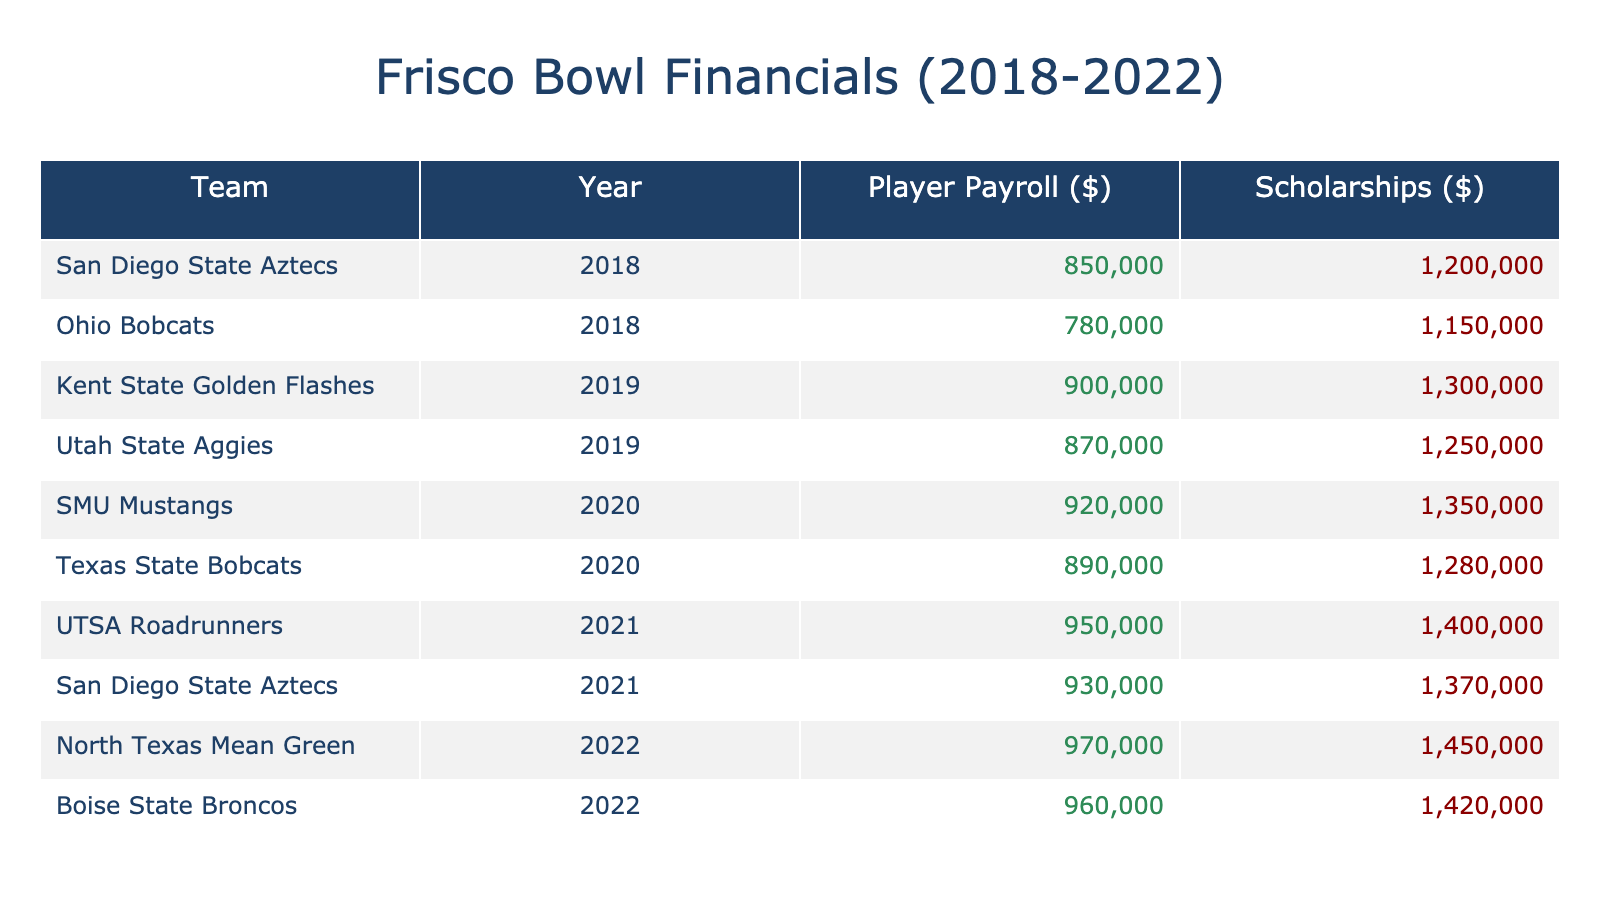What was the player payroll for the Ohio Bobcats in 2018? The table shows that the player payroll for the Ohio Bobcats in 2018 is $780,000.
Answer: $780,000 Which team had the highest scholarships amount in 2021? In 2021, the UTSA Roadrunners had scholarships amounting to $1,400,000, which is the highest compared to other teams in that year.
Answer: $1,400,000 What is the total player payroll for the teams in 2019? Adding the player payrolls for the teams in 2019: $900,000 (Kent State) + $870,000 (Utah State) = $1,770,000.
Answer: $1,770,000 Did the player payroll for the SMU Mustangs increase from 2020 to 2021? The player payroll for the SMU Mustangs in 2020 is $920,000, while in 2021 there are no data points for SMU Mustangs. Thus, we cannot determine an increase.
Answer: No Which year had the highest total scholarships amount across all teams? To find the total scholarships for each year, sum up the values: In 2018, $2,200,000, in 2019, $2,550,000, in 2020, $2,580,000, in 2021, $2,910,000, and in 2022, $2,900,000. The year 2021 had the highest total at $2,910,000.
Answer: 2021 What is the average player payroll for all teams across the five years? The total player payroll over the years is: $850,000 + $780,000 + $900,000 + $870,000 + $920,000 + $890,000 + $950,000 + $930,000 + $970,000 + $960,000 = $9,920,000. Dividing this by 10 gives us an average of $992,000.
Answer: $992,000 Was the player payroll for the North Texas Mean Green greater than $950,000 in 2022? The player payroll for the North Texas Mean Green in 2022 is $970,000, which is indeed greater than $950,000.
Answer: Yes How much did the player payroll increase from 2020 to 2021 for the UTSA Roadrunners? For the UTSA Roadrunners, the player payroll in 2021 is $950,000, and in 2020 it is $890,000. The increase is $950,000 - $890,000 = $60,000.
Answer: $60,000 